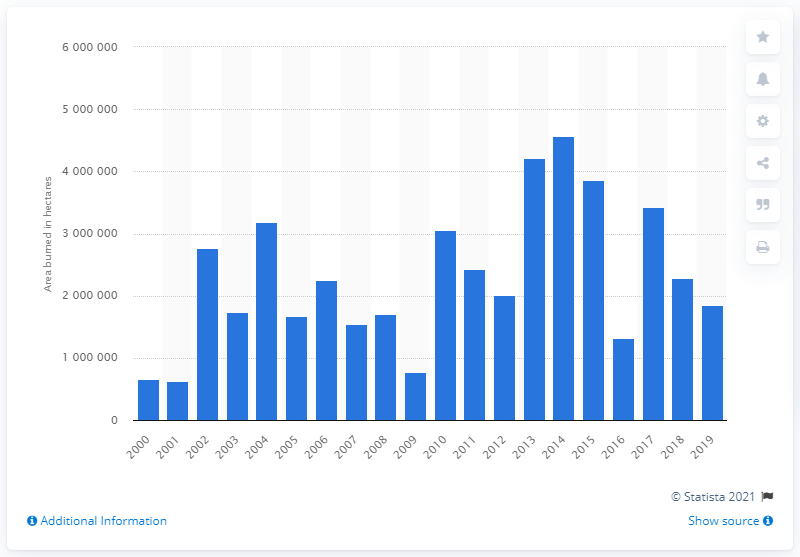Highlight a few significant elements in this photo. In 2019, a significant amount of land in Canada was burned by forest fires, with the total acreage affected amounting to 1,842,612 acres. 